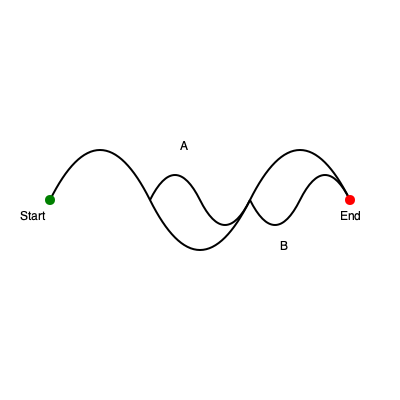In this visual representation of societal development paths, how many distinct routes can be taken from the starting point (green) to the endpoint (red), considering that each decision point allows for only forward movement? To solve this puzzle, we need to analyze the structure of the maze-like paths:

1. The path begins at the green point (start) and ends at the red point (end).
2. There are two main decision points in the maze, labeled A and B.
3. At each decision point, we have two choices: to take the upper path or the lower path.
4. We can only move forward, not backward.

Let's count the possible routes:

1. Take the upper path at both A and B
2. Take the upper path at A, lower path at B
3. Take the lower path at A, upper path at B
4. Take the lower path at both A and B

Each of these routes represents a different possibility for societal development, symbolizing how choices in technology, philosophy, or policy can lead to divergent outcomes.

The maze structure challenges the deterministic view by showing multiple possible paths, emphasizing that societal development is not a linear, predetermined process but rather a complex system with various potential outcomes based on collective choices and unforeseen factors.
Answer: 4 distinct routes 